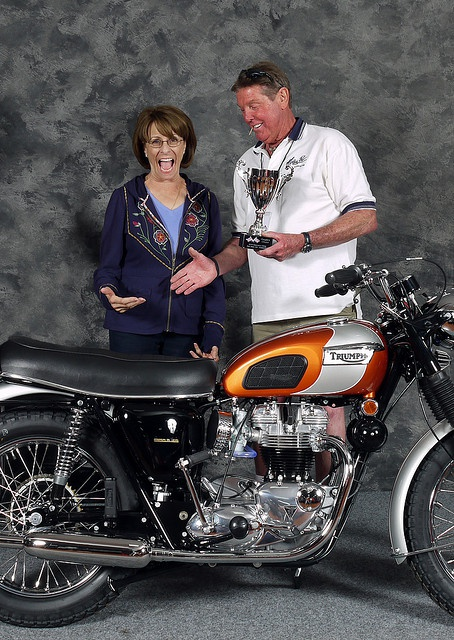Describe the objects in this image and their specific colors. I can see motorcycle in gray, black, darkgray, and lightgray tones, people in gray, lightgray, brown, and black tones, and people in gray, black, navy, and tan tones in this image. 